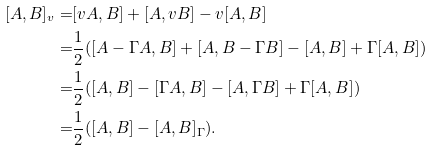Convert formula to latex. <formula><loc_0><loc_0><loc_500><loc_500>[ A , B ] _ { v } = & [ v A , B ] + [ A , v B ] - v [ A , B ] \\ = & \frac { 1 } { 2 } ( [ A - \Gamma A , B ] + [ A , B - \Gamma B ] - [ A , B ] + \Gamma [ A , B ] ) \\ = & \frac { 1 } { 2 } ( [ A , B ] - [ \Gamma A , B ] - [ A , \Gamma B ] + \Gamma [ A , B ] ) \\ = & \frac { 1 } { 2 } ( [ A , B ] - [ A , B ] _ { \Gamma } ) .</formula> 